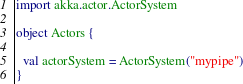Convert code to text. <code><loc_0><loc_0><loc_500><loc_500><_Scala_>import akka.actor.ActorSystem

object Actors {

  val actorSystem = ActorSystem("mypipe")
}
</code> 